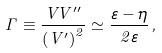<formula> <loc_0><loc_0><loc_500><loc_500>\Gamma \equiv \frac { V V ^ { \prime \prime } } { \left ( V ^ { \prime } \right ) ^ { 2 } } \simeq \frac { \varepsilon - \eta } { 2 \varepsilon } \, ,</formula> 